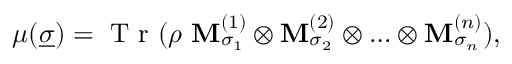<formula> <loc_0><loc_0><loc_500><loc_500>\mu ( \underline { \sigma } ) = T r ( \rho M _ { \sigma _ { 1 } } ^ { ( 1 ) } \otimes M _ { \sigma _ { 2 } } ^ { ( 2 ) } \otimes \dots \otimes M _ { \sigma _ { n } } ^ { ( n ) } ) ,</formula> 